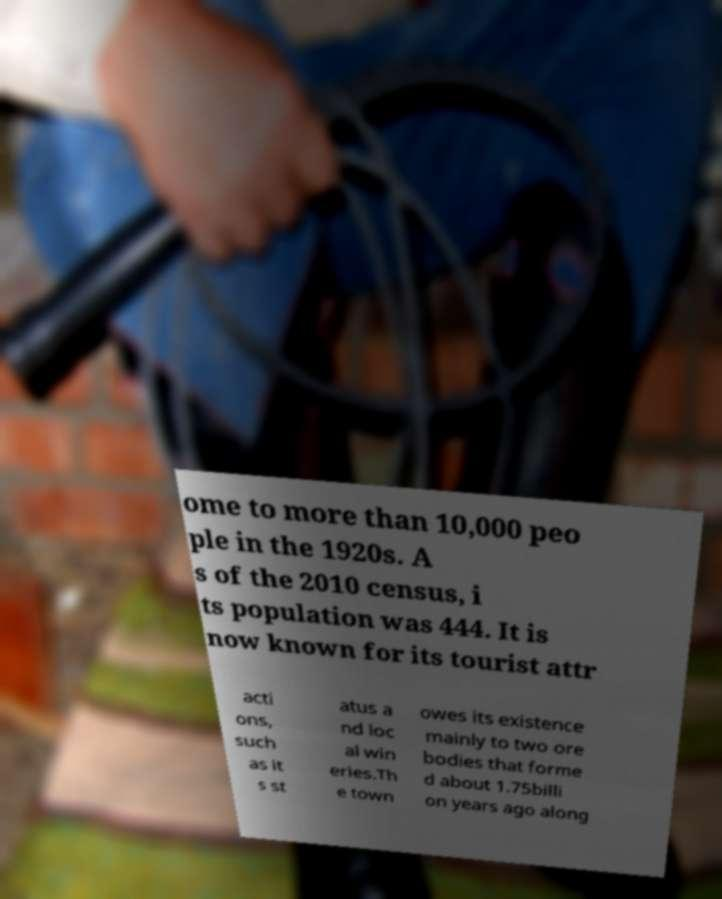I need the written content from this picture converted into text. Can you do that? ome to more than 10,000 peo ple in the 1920s. A s of the 2010 census, i ts population was 444. It is now known for its tourist attr acti ons, such as it s st atus a nd loc al win eries.Th e town owes its existence mainly to two ore bodies that forme d about 1.75billi on years ago along 